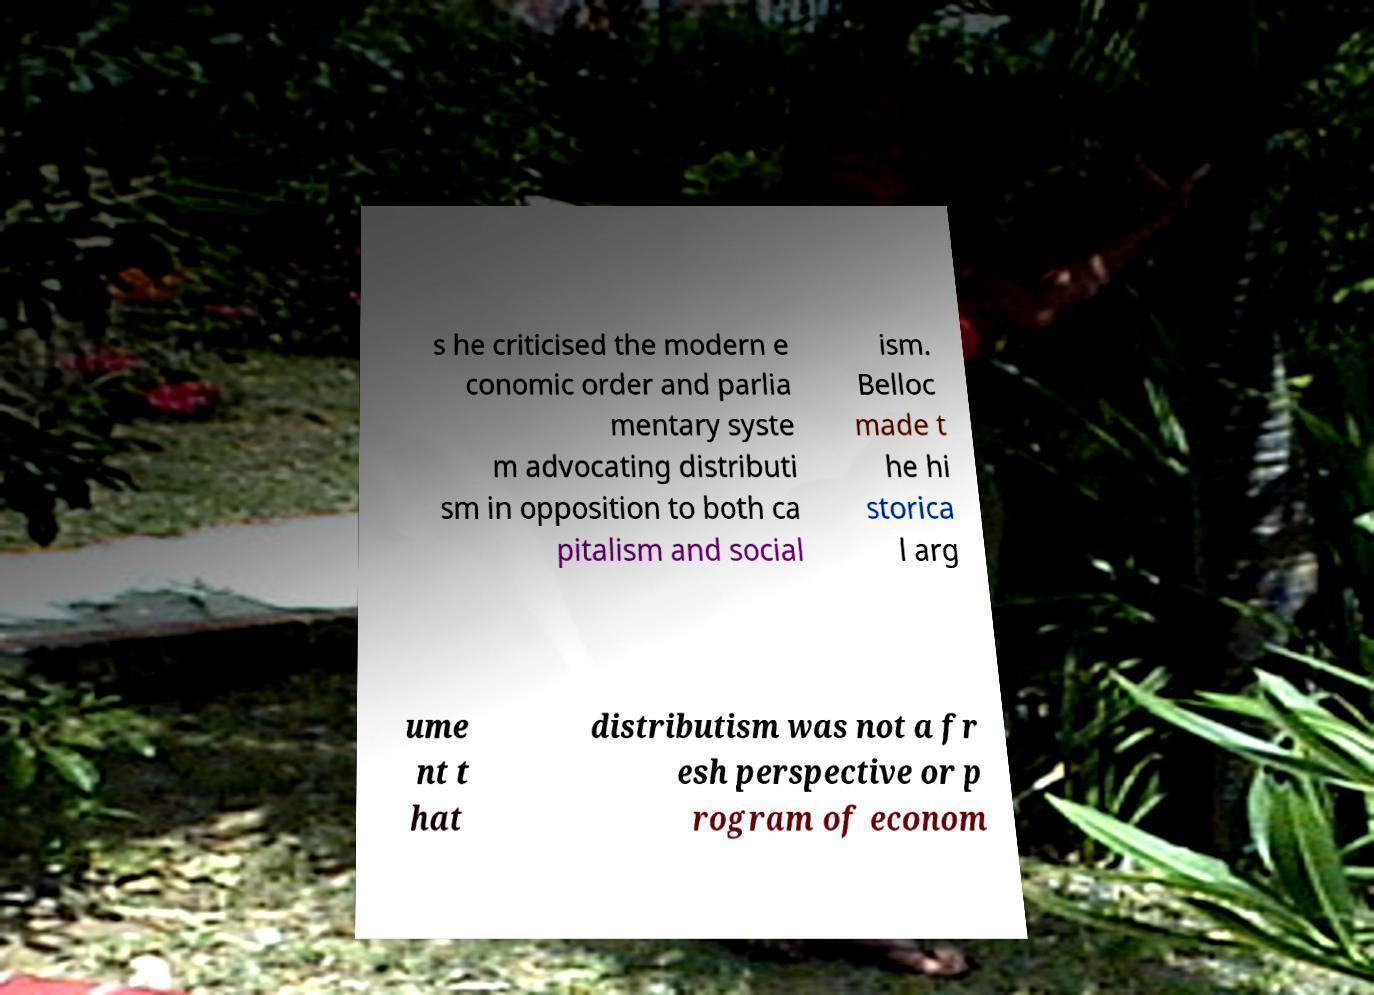Can you read and provide the text displayed in the image?This photo seems to have some interesting text. Can you extract and type it out for me? s he criticised the modern e conomic order and parlia mentary syste m advocating distributi sm in opposition to both ca pitalism and social ism. Belloc made t he hi storica l arg ume nt t hat distributism was not a fr esh perspective or p rogram of econom 